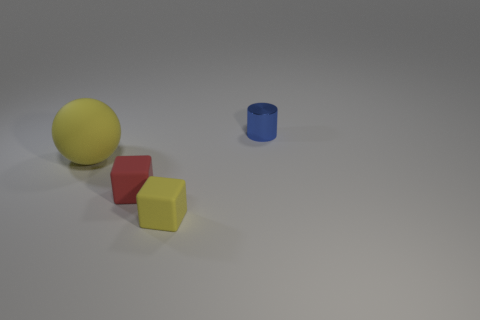Add 1 large cyan metal balls. How many objects exist? 5 Subtract all yellow blocks. How many blocks are left? 1 Subtract 0 blue spheres. How many objects are left? 4 Subtract all balls. How many objects are left? 3 Subtract all gray spheres. Subtract all gray cubes. How many spheres are left? 1 Subtract all cyan cylinders. How many blue cubes are left? 0 Subtract all yellow rubber blocks. Subtract all small red metallic objects. How many objects are left? 3 Add 1 tiny objects. How many tiny objects are left? 4 Add 1 tiny metallic things. How many tiny metallic things exist? 2 